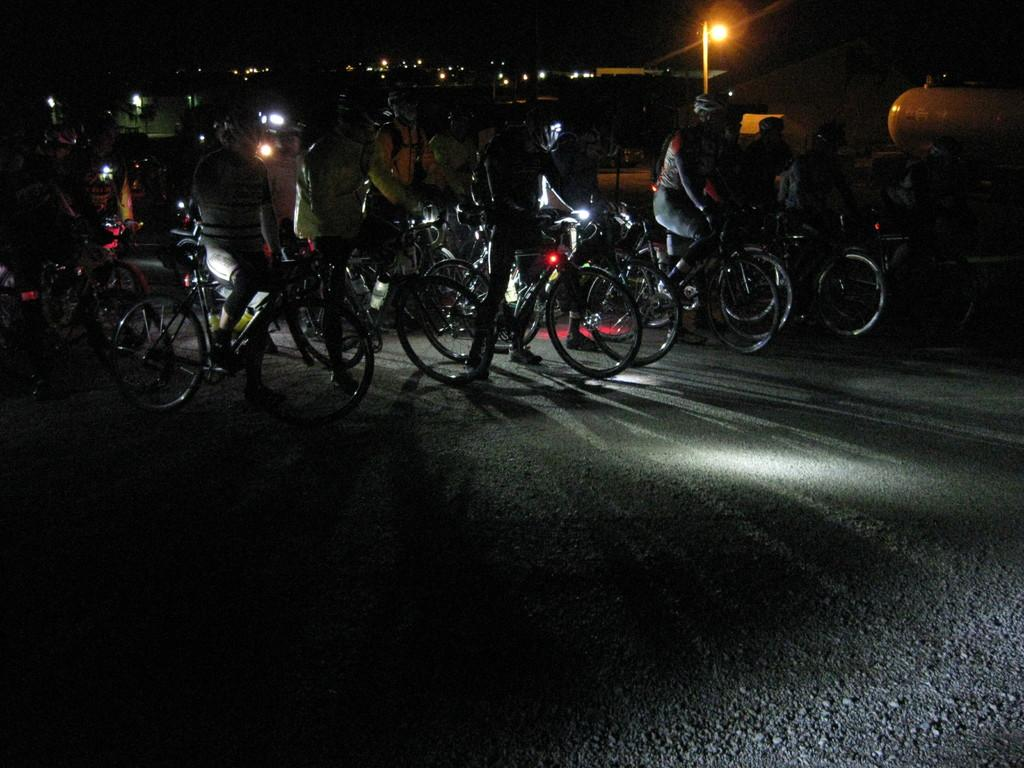What are the people in the image doing? The people in the image are riding bicycles. What safety precaution are the people taking while riding bicycles? The people are wearing helmets. What can be seen in the image besides the people and bicycles? There are lights visible in the image. What is the color of the background in the image? The background of the image is dark. What type of growth can be seen on the bicycles in the image? There is no growth visible on the bicycles in the image. What trick are the people performing on their bicycles in the image? There is no trick being performed by the people in the image; they are simply riding bicycles. 